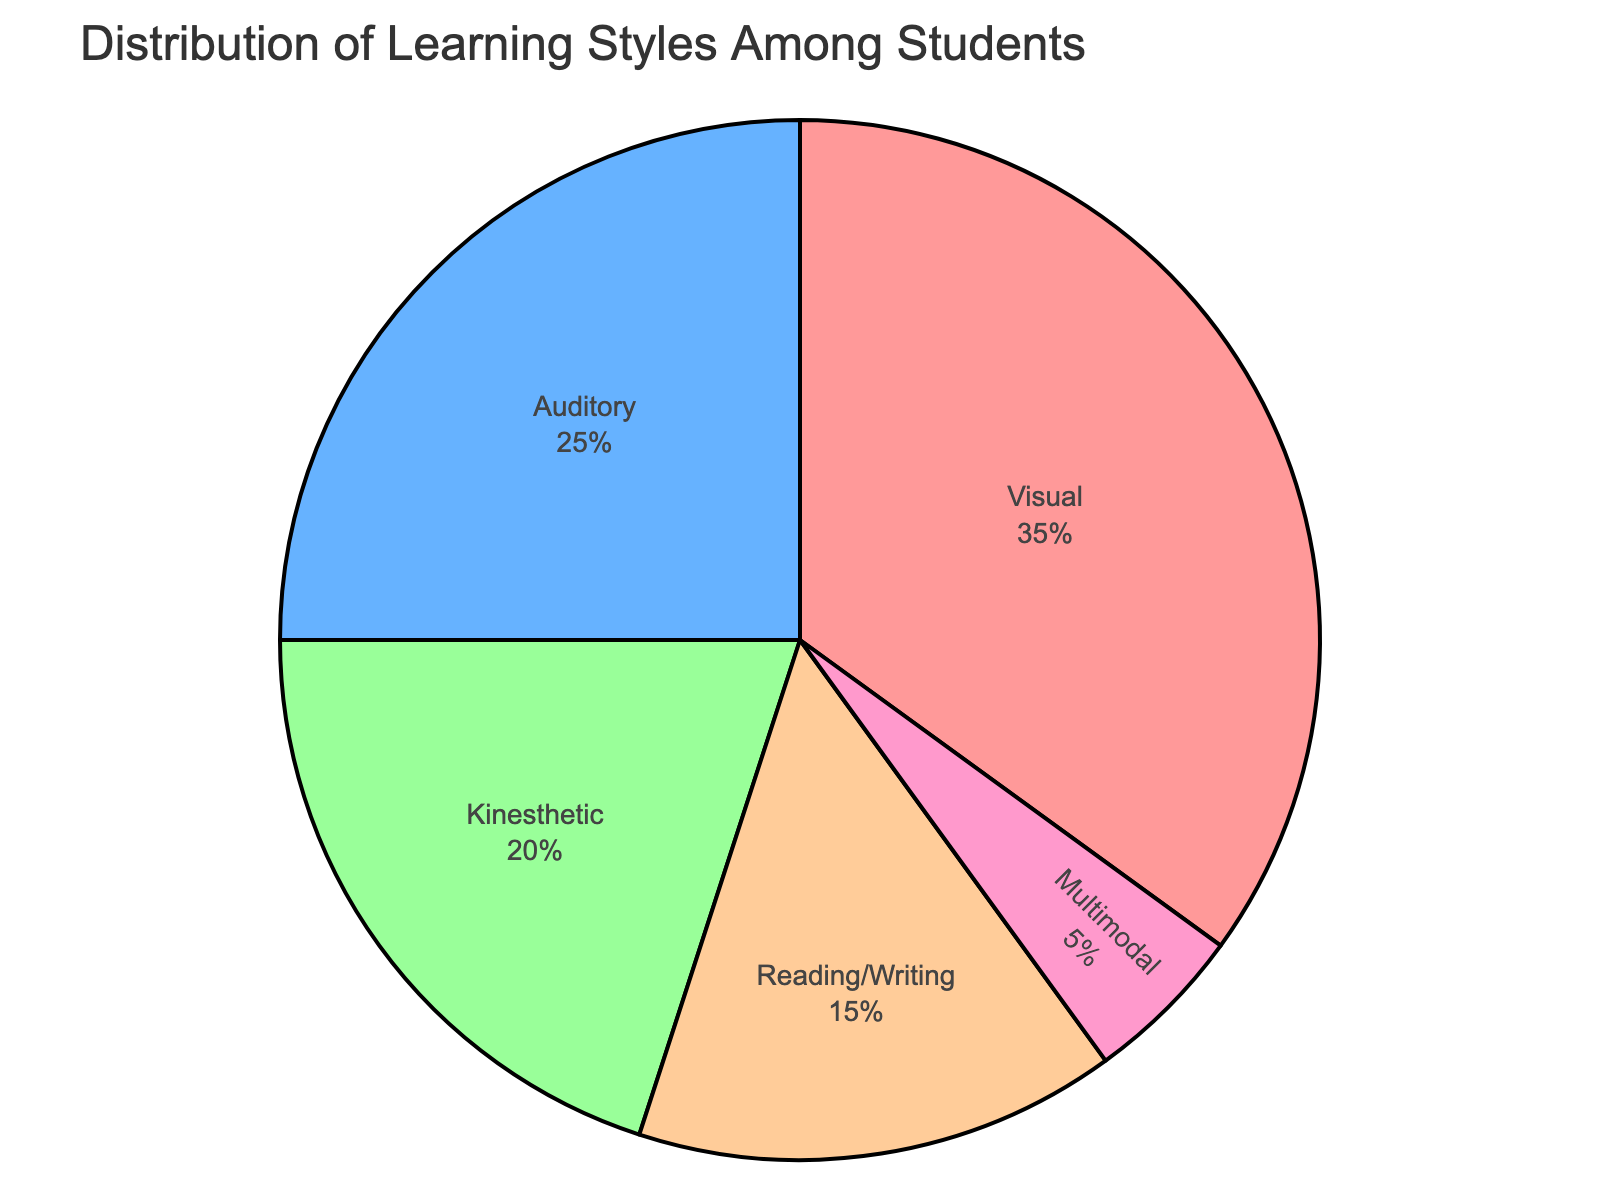What percentage of students prefer Visual and Auditory learning styles combined? First, find the percentage for Visual learning style, which is 35%. Then, find the percentage for Auditory learning style, which is 25%. Add the two percentages together: 35% + 25% = 60%.
Answer: 60% What is the difference in the percentages of Visual and Kinesthetic learning styles? Find the percentage for Visual learning style, which is 35%. Then, find the percentage for Kinesthetic learning style, which is 20%. Subtract the Kinesthetic percentage from the Visual percentage: 35% - 20% = 15%.
Answer: 15% Which learning style has the smallest percentage? Look at the pie chart and identify the learning style with the smallest segment. The smallest segment corresponds to the Multimodal learning style, which has a percentage of 5%.
Answer: Multimodal Between Reading/Writing and Auditory learning styles, which one is more preferred by students? Compare the percentages of the Reading/Writing and Auditory learning styles. Reading/Writing has 15%, and Auditory has 25%. Since 25% is greater than 15%, Auditory is more preferred.
Answer: Auditory What is the average percentage of students who prefer Kinesthetic and Reading/Writing learning styles? Find the percentage for Kinesthetic, which is 20%. Then, find the percentage for Reading/Writing, which is 15%. Add the two percentages together: 20% + 15% = 35%. Divide by 2 to find the average = 35% / 2 = 17.5%.
Answer: 17.5% What is the total percentage of students preferring non-visual learning styles? Subtract the percentage of Visual learning style (35%) from 100% as Visual is the only style not to be included in this group: 100% - 35% = 65%.
Answer: 65% Which segment of the chart is represented by 'Kinesthetic'? Look for the color associated with Kinesthetic in the figure. The Kinesthetic segment is represented by the third-largest segment, which is green-colored.
Answer: Green-colored How many times larger is the Visual learning style compared to the Multimodal learning style? Find the percentage for Visual, which is 35%, and for Multimodal, which is 5%. Divide the Visual percentage by the Multimodal percentage: 35% / 5% = 7.
Answer: 7 